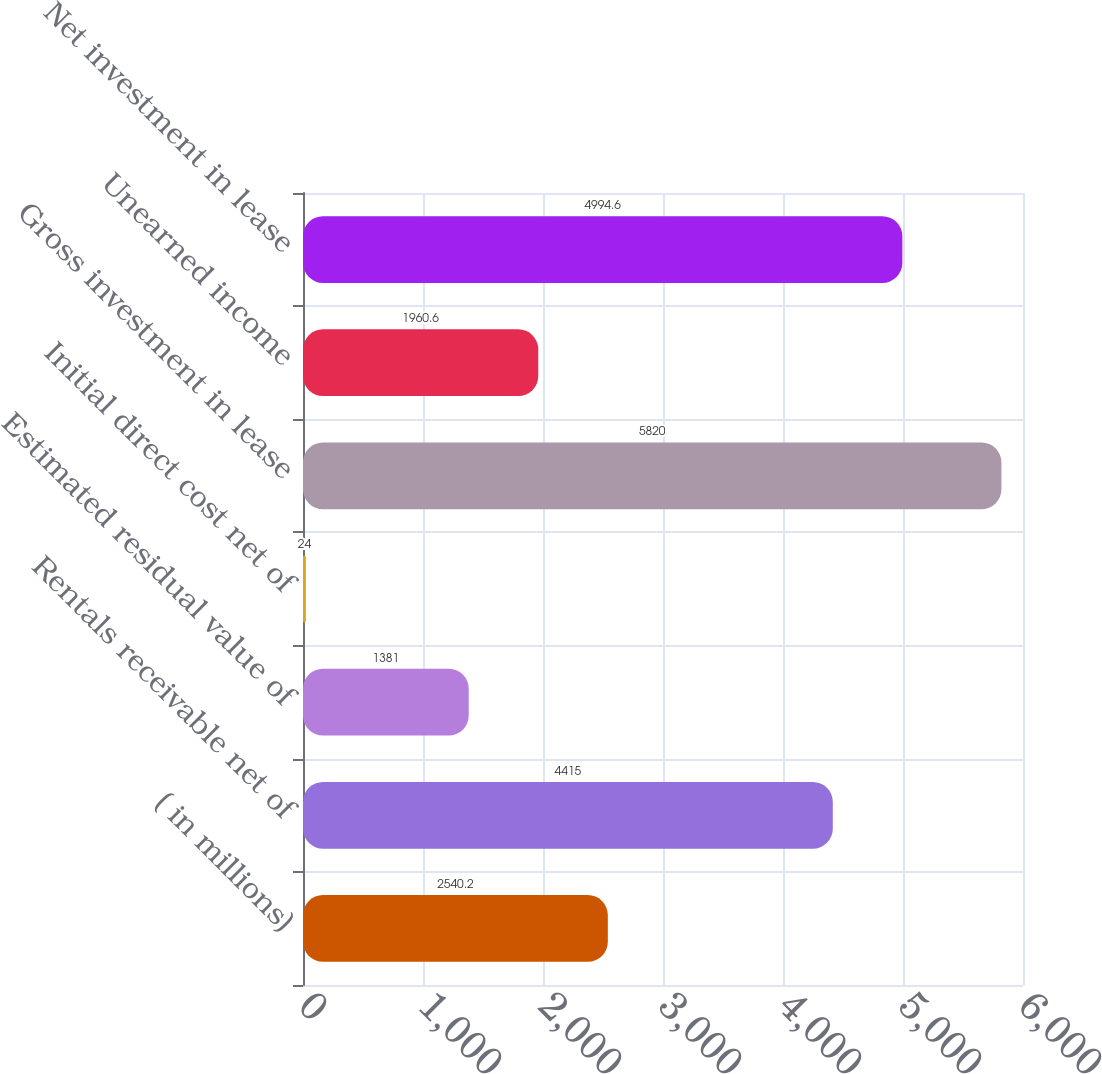Convert chart to OTSL. <chart><loc_0><loc_0><loc_500><loc_500><bar_chart><fcel>( in millions)<fcel>Rentals receivable net of<fcel>Estimated residual value of<fcel>Initial direct cost net of<fcel>Gross investment in lease<fcel>Unearned income<fcel>Net investment in lease<nl><fcel>2540.2<fcel>4415<fcel>1381<fcel>24<fcel>5820<fcel>1960.6<fcel>4994.6<nl></chart> 